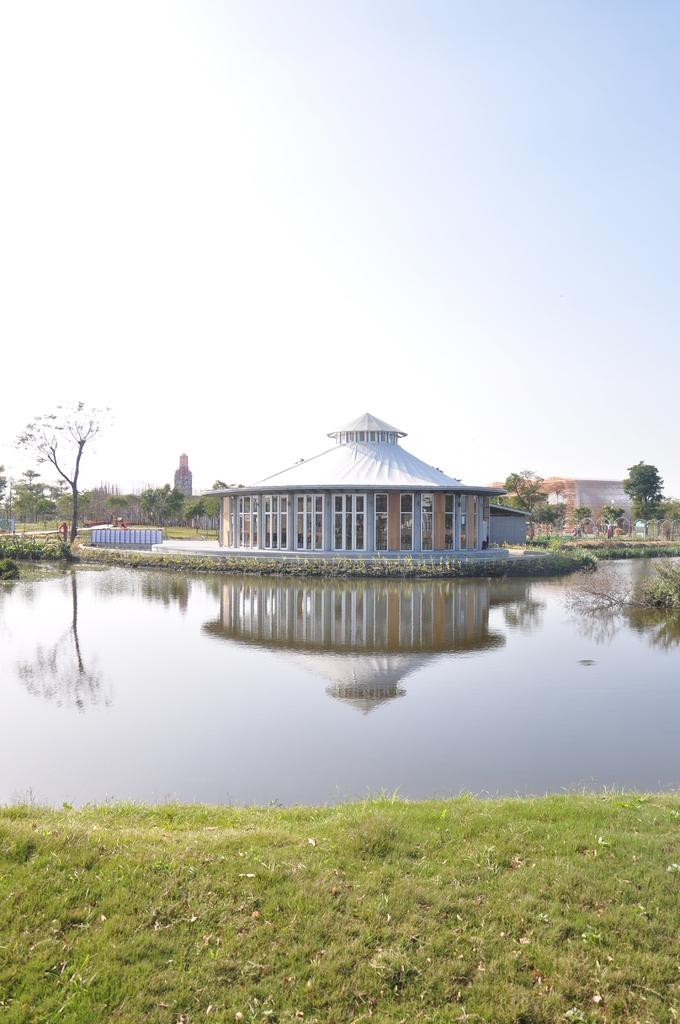What type of vegetation is present on the ground in the image? There is grass on the ground in the image. What color is the grass? The grass is green. What body of water can be seen in the image? There is a small water pond in the image. What is in the water pond? There is water in the water pond. What structure is located in the middle of the image? There is a house in the middle of the image. What is visible at the top of the image? The sky is visible at the top of the image. How many rabbits can be seen at the edge of the water pond in the image? There are no rabbits present in the image. What type of shock can be seen coming from the house in the image? There is no shock present in the image; the house is a static structure. 